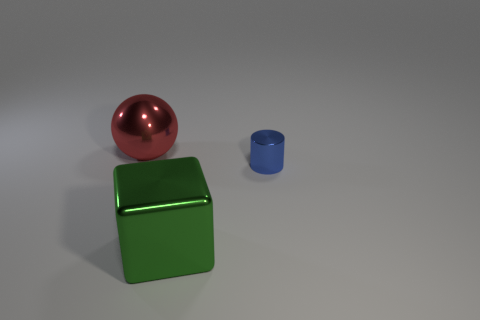What is the shape of the big metallic object in front of the blue shiny thing?
Ensure brevity in your answer.  Cube. Is the number of tiny blue objects behind the big red shiny thing less than the number of tiny objects that are on the left side of the large green thing?
Give a very brief answer. No. Is the large thing that is in front of the big red metal sphere made of the same material as the object that is to the right of the block?
Your response must be concise. Yes. What is the shape of the large green thing?
Keep it short and to the point. Cube. Is the number of small blue metallic things that are in front of the tiny metal thing greater than the number of big green shiny cubes behind the large red object?
Keep it short and to the point. No. There is a thing that is on the left side of the green metallic block; is it the same shape as the shiny object that is on the right side of the big shiny block?
Provide a succinct answer. No. How many other objects are there of the same size as the cylinder?
Your answer should be compact. 0. What is the size of the ball?
Provide a short and direct response. Large. Is the material of the big object left of the large green metal thing the same as the block?
Your answer should be very brief. Yes. There is a large object that is to the right of the big metal ball; is it the same color as the big ball?
Offer a terse response. No. 